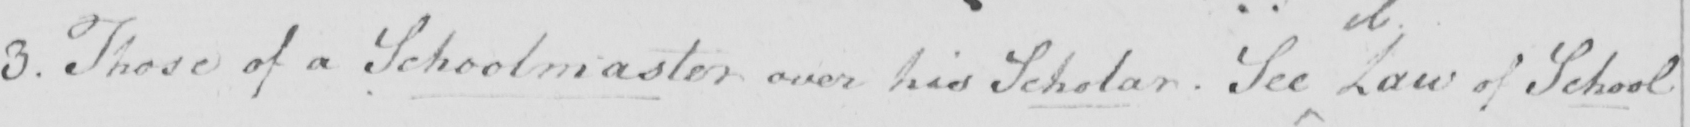What does this handwritten line say? 3 . Those of a Schoolmaster over his Scholar . See Law of School 